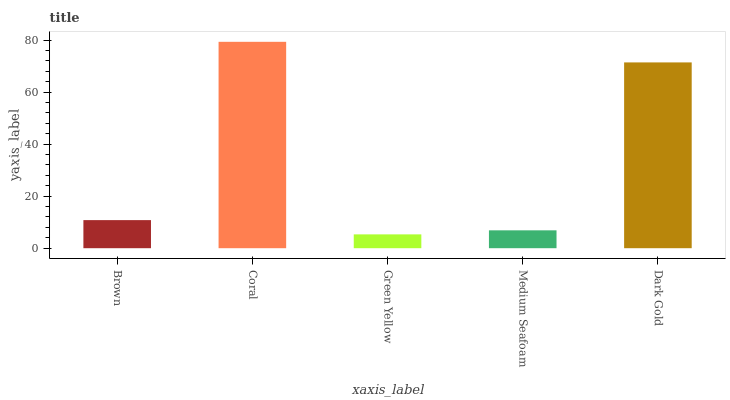Is Green Yellow the minimum?
Answer yes or no. Yes. Is Coral the maximum?
Answer yes or no. Yes. Is Coral the minimum?
Answer yes or no. No. Is Green Yellow the maximum?
Answer yes or no. No. Is Coral greater than Green Yellow?
Answer yes or no. Yes. Is Green Yellow less than Coral?
Answer yes or no. Yes. Is Green Yellow greater than Coral?
Answer yes or no. No. Is Coral less than Green Yellow?
Answer yes or no. No. Is Brown the high median?
Answer yes or no. Yes. Is Brown the low median?
Answer yes or no. Yes. Is Green Yellow the high median?
Answer yes or no. No. Is Medium Seafoam the low median?
Answer yes or no. No. 